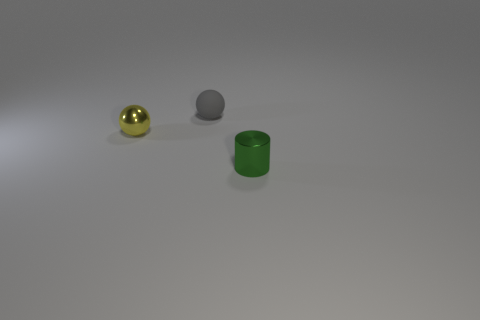There is a metallic object that is on the left side of the thing on the right side of the sphere behind the yellow shiny thing; what is its color?
Provide a succinct answer. Yellow. There is a small gray matte thing; is it the same shape as the small metallic object behind the green cylinder?
Ensure brevity in your answer.  Yes. There is a tiny thing that is left of the green metal cylinder and in front of the gray sphere; what color is it?
Ensure brevity in your answer.  Yellow. Are there any shiny objects of the same shape as the rubber object?
Your response must be concise. Yes. Is the color of the small rubber object the same as the metallic cylinder?
Keep it short and to the point. No. There is a shiny object to the left of the green object; is there a yellow ball to the left of it?
Give a very brief answer. No. What number of objects are either objects in front of the gray ball or things behind the cylinder?
Provide a succinct answer. 3. What number of things are either yellow shiny cylinders or tiny things on the left side of the small green cylinder?
Provide a succinct answer. 2. There is a ball that is on the right side of the sphere left of the tiny sphere behind the small yellow metal ball; what is its size?
Provide a short and direct response. Small. There is a green object that is the same size as the gray rubber ball; what is its material?
Give a very brief answer. Metal. 